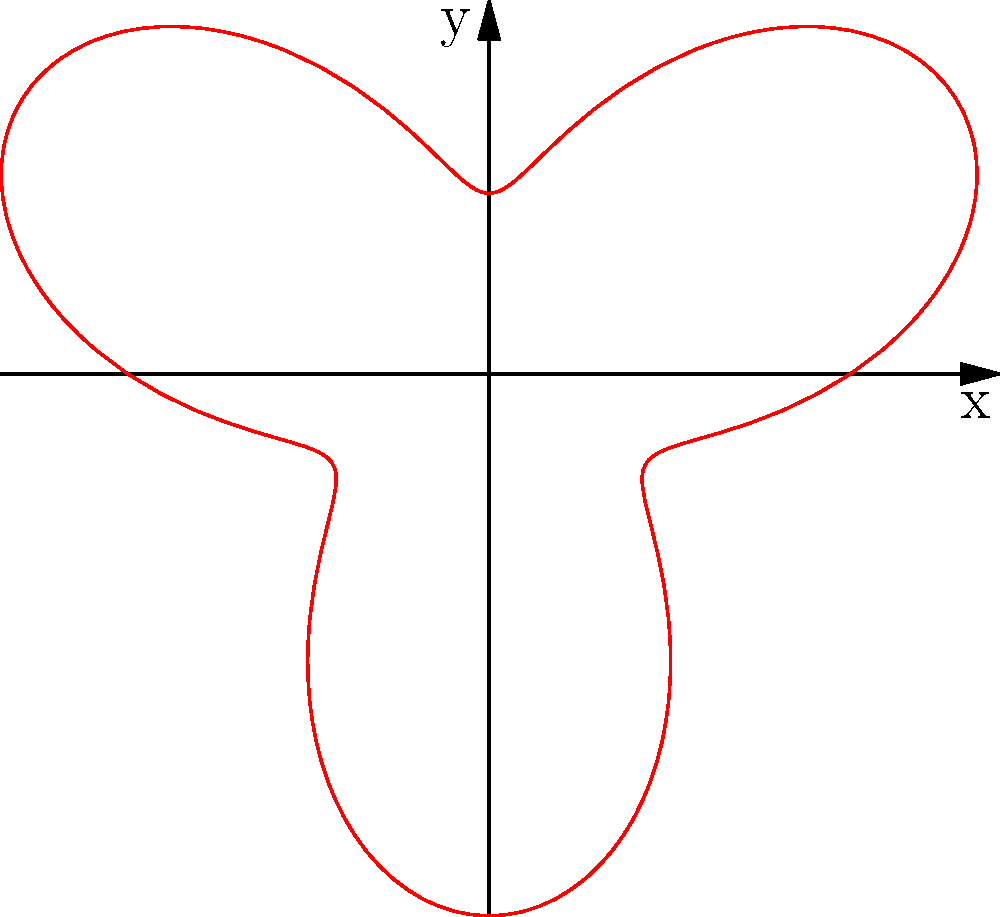The polar curve shown represents the acceleration curve of a race car engine. The radius represents the acceleration in g-forces, and the angle represents the engine RPM from 0 to 6000 (scaled to 0 to 2π). What is the maximum acceleration achieved by this engine, and at approximately what RPM does it occur? To solve this problem, we need to analyze the polar curve:

1. The equation of the curve is given by $r = 2 + \sin(3\theta)$, where $r$ is the radius (acceleration) and $\theta$ is the angle (RPM).

2. To find the maximum acceleration, we need to find the maximum value of $r$:
   $r_{max} = 2 + \sin(3\theta)_{max} = 2 + 1 = 3$ g-forces

3. The maximum occurs when $\sin(3\theta) = 1$, which happens when $3\theta = \frac{\pi}{2}, \frac{5\pi}{2}, \frac{9\pi}{2}$, etc.

4. The first occurrence is at $\theta = \frac{\pi}{6}$, which corresponds to $\frac{1}{12}$ of the total RPM range.

5. Since the total range is 6000 RPM, the maximum acceleration occurs at:
   $\frac{1}{12} \times 6000 = 500$ RPM

Therefore, the maximum acceleration is 3 g-forces and occurs at approximately 500 RPM.
Answer: 3 g-forces at 500 RPM 